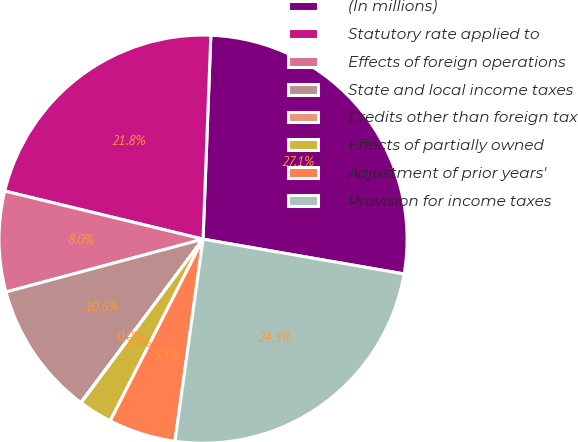<chart> <loc_0><loc_0><loc_500><loc_500><pie_chart><fcel>(In millions)<fcel>Statutory rate applied to<fcel>Effects of foreign operations<fcel>State and local income taxes<fcel>Credits other than foreign tax<fcel>Effects of partially owned<fcel>Adjustment of prior years'<fcel>Provision for income taxes<nl><fcel>27.12%<fcel>21.82%<fcel>7.96%<fcel>10.61%<fcel>0.03%<fcel>2.67%<fcel>5.32%<fcel>24.47%<nl></chart> 